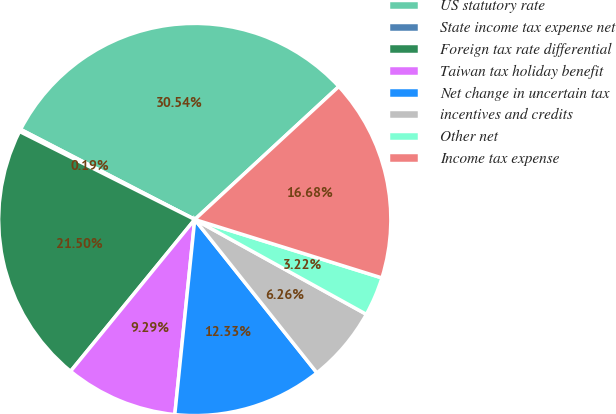Convert chart to OTSL. <chart><loc_0><loc_0><loc_500><loc_500><pie_chart><fcel>US statutory rate<fcel>State income tax expense net<fcel>Foreign tax rate differential<fcel>Taiwan tax holiday benefit<fcel>Net change in uncertain tax<fcel>incentives and credits<fcel>Other net<fcel>Income tax expense<nl><fcel>30.54%<fcel>0.19%<fcel>21.5%<fcel>9.29%<fcel>12.33%<fcel>6.26%<fcel>3.22%<fcel>16.68%<nl></chart> 